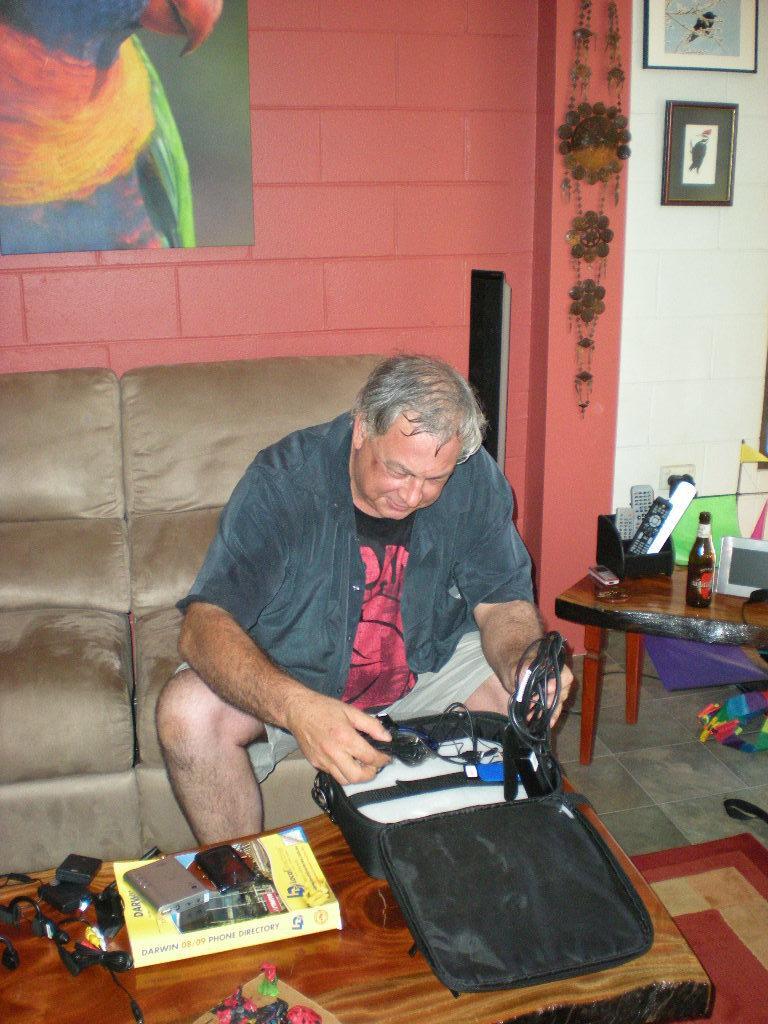Can you describe this image briefly? The image is taken inside the room. In the image there is a man sitting on couch in front of a table. On table we can see suitcase,wires,book,mobile and right side of the image we can see a table. On table there is a mobile,remote,bottle,wall which is in white color,photo frames. In background there wall which is in red color and a painting. 